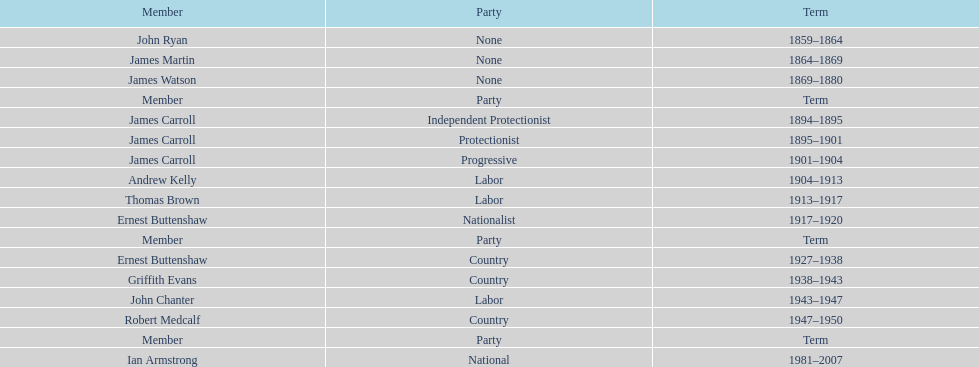How long did ian armstrong serve? 26 years. 